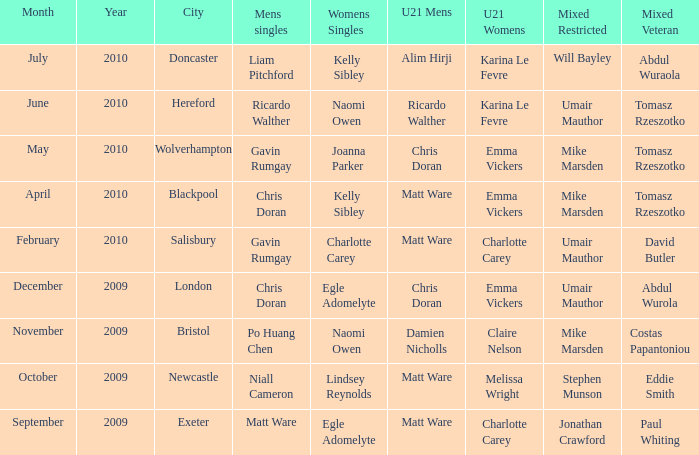When Matt Ware won the mens singles, who won the mixed restricted? Jonathan Crawford. Help me parse the entirety of this table. {'header': ['Month', 'Year', 'City', 'Mens singles', 'Womens Singles', 'U21 Mens', 'U21 Womens', 'Mixed Restricted', 'Mixed Veteran'], 'rows': [['July', '2010', 'Doncaster', 'Liam Pitchford', 'Kelly Sibley', 'Alim Hirji', 'Karina Le Fevre', 'Will Bayley', 'Abdul Wuraola'], ['June', '2010', 'Hereford', 'Ricardo Walther', 'Naomi Owen', 'Ricardo Walther', 'Karina Le Fevre', 'Umair Mauthor', 'Tomasz Rzeszotko'], ['May', '2010', 'Wolverhampton', 'Gavin Rumgay', 'Joanna Parker', 'Chris Doran', 'Emma Vickers', 'Mike Marsden', 'Tomasz Rzeszotko'], ['April', '2010', 'Blackpool', 'Chris Doran', 'Kelly Sibley', 'Matt Ware', 'Emma Vickers', 'Mike Marsden', 'Tomasz Rzeszotko'], ['February', '2010', 'Salisbury', 'Gavin Rumgay', 'Charlotte Carey', 'Matt Ware', 'Charlotte Carey', 'Umair Mauthor', 'David Butler'], ['December', '2009', 'London', 'Chris Doran', 'Egle Adomelyte', 'Chris Doran', 'Emma Vickers', 'Umair Mauthor', 'Abdul Wurola'], ['November', '2009', 'Bristol', 'Po Huang Chen', 'Naomi Owen', 'Damien Nicholls', 'Claire Nelson', 'Mike Marsden', 'Costas Papantoniou'], ['October', '2009', 'Newcastle', 'Niall Cameron', 'Lindsey Reynolds', 'Matt Ware', 'Melissa Wright', 'Stephen Munson', 'Eddie Smith'], ['September', '2009', 'Exeter', 'Matt Ware', 'Egle Adomelyte', 'Matt Ware', 'Charlotte Carey', 'Jonathan Crawford', 'Paul Whiting']]} 